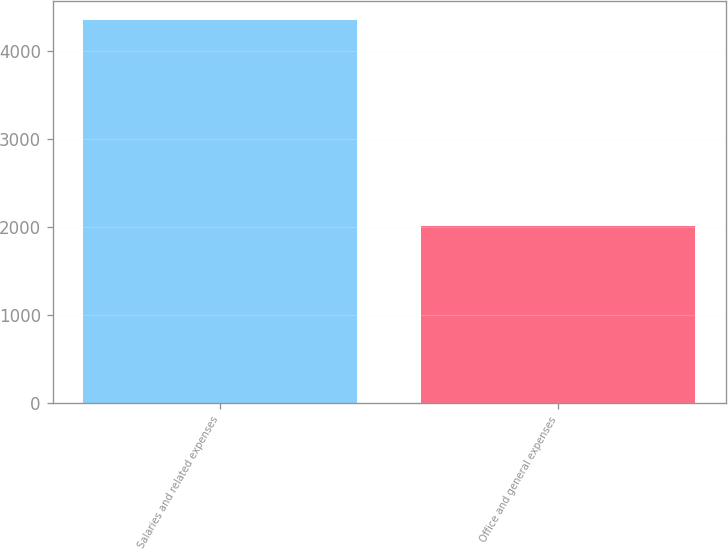Convert chart to OTSL. <chart><loc_0><loc_0><loc_500><loc_500><bar_chart><fcel>Salaries and related expenses<fcel>Office and general expenses<nl><fcel>4342.6<fcel>2013.3<nl></chart> 